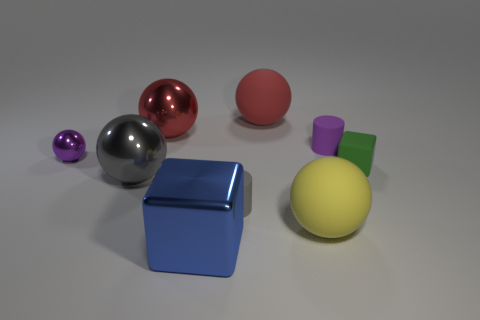Subtract all yellow balls. How many balls are left? 4 Subtract all brown balls. Subtract all cyan cubes. How many balls are left? 5 Subtract all cubes. How many objects are left? 7 Add 3 large blue shiny cubes. How many large blue shiny cubes exist? 4 Subtract 0 yellow blocks. How many objects are left? 9 Subtract all gray matte things. Subtract all large red balls. How many objects are left? 6 Add 4 big yellow objects. How many big yellow objects are left? 5 